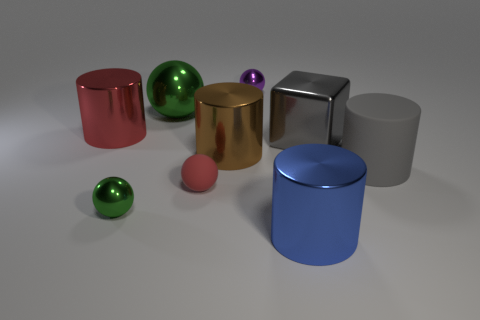There is a small metal object that is to the right of the large green ball; what is its shape?
Offer a terse response. Sphere. There is a matte thing that is on the left side of the big blue thing; is its color the same as the small shiny thing right of the large green shiny object?
Provide a succinct answer. No. What size is the other shiny sphere that is the same color as the large metal sphere?
Keep it short and to the point. Small. Are there any spheres?
Your answer should be compact. Yes. What shape is the small shiny thing that is to the left of the green shiny ball behind the big metallic thing that is left of the tiny green metal thing?
Provide a short and direct response. Sphere. There is a metal block; what number of large metallic things are on the left side of it?
Offer a terse response. 4. Does the block that is in front of the big ball have the same material as the purple sphere?
Make the answer very short. Yes. What number of other objects are there of the same shape as the small rubber object?
Offer a terse response. 3. How many big cubes are in front of the rubber thing that is to the left of the small metallic thing to the right of the tiny green object?
Your answer should be very brief. 0. What is the color of the shiny cylinder in front of the red matte sphere?
Offer a terse response. Blue. 